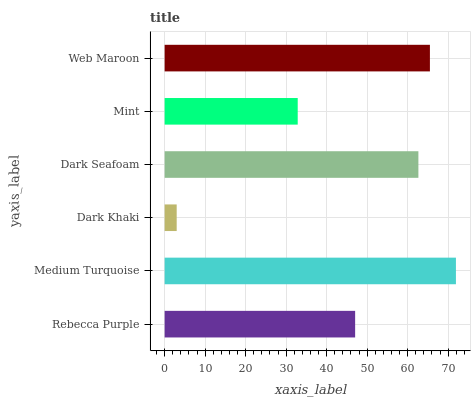Is Dark Khaki the minimum?
Answer yes or no. Yes. Is Medium Turquoise the maximum?
Answer yes or no. Yes. Is Medium Turquoise the minimum?
Answer yes or no. No. Is Dark Khaki the maximum?
Answer yes or no. No. Is Medium Turquoise greater than Dark Khaki?
Answer yes or no. Yes. Is Dark Khaki less than Medium Turquoise?
Answer yes or no. Yes. Is Dark Khaki greater than Medium Turquoise?
Answer yes or no. No. Is Medium Turquoise less than Dark Khaki?
Answer yes or no. No. Is Dark Seafoam the high median?
Answer yes or no. Yes. Is Rebecca Purple the low median?
Answer yes or no. Yes. Is Mint the high median?
Answer yes or no. No. Is Dark Khaki the low median?
Answer yes or no. No. 